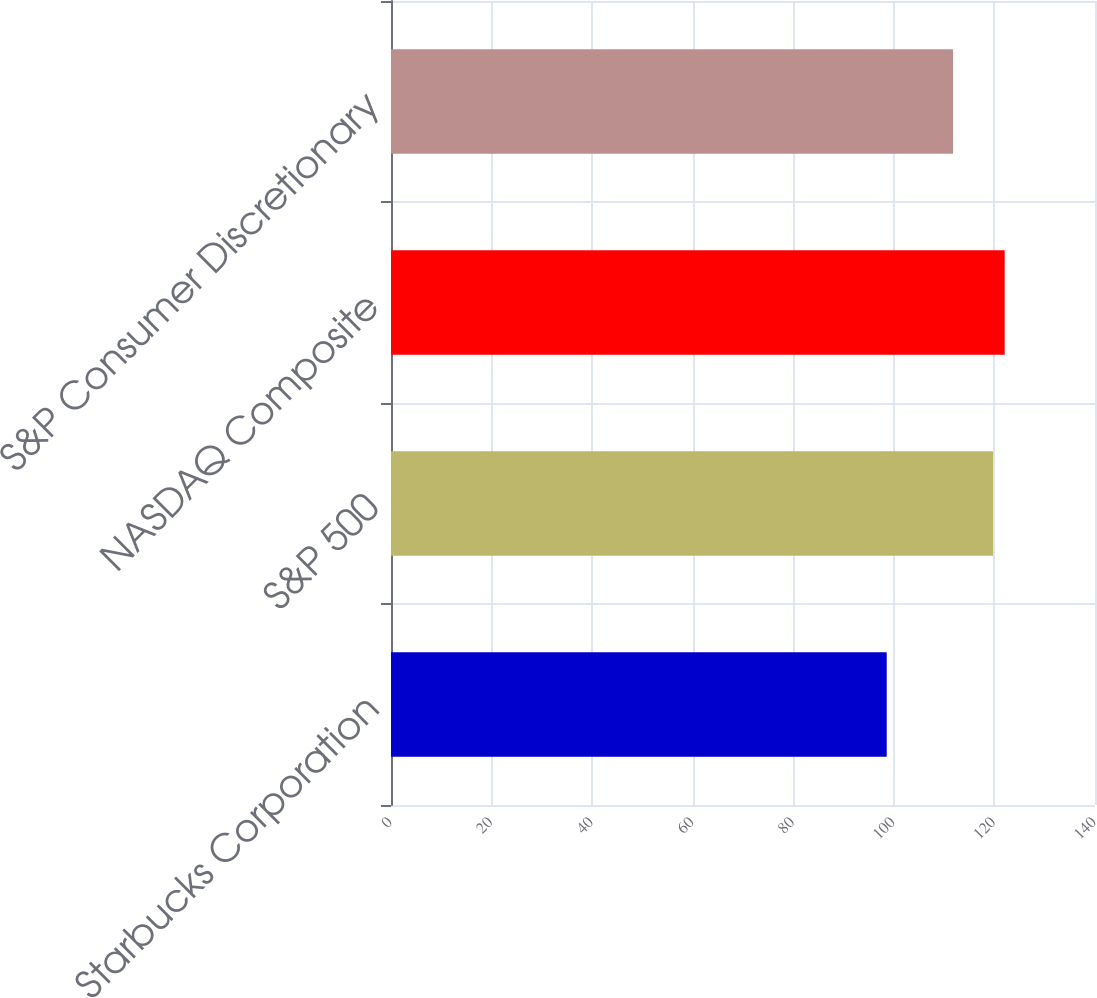<chart> <loc_0><loc_0><loc_500><loc_500><bar_chart><fcel>Starbucks Corporation<fcel>S&P 500<fcel>NASDAQ Composite<fcel>S&P Consumer Discretionary<nl><fcel>98.58<fcel>119.73<fcel>122.04<fcel>111.77<nl></chart> 